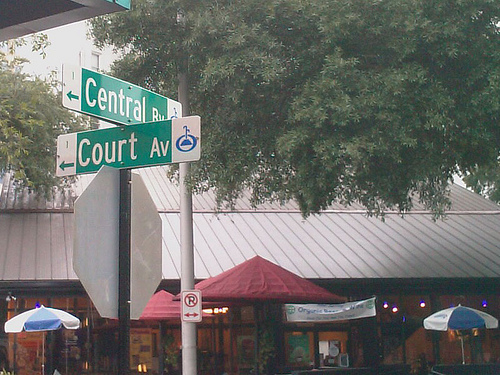Identify the text displayed in this image. Central Court AV 